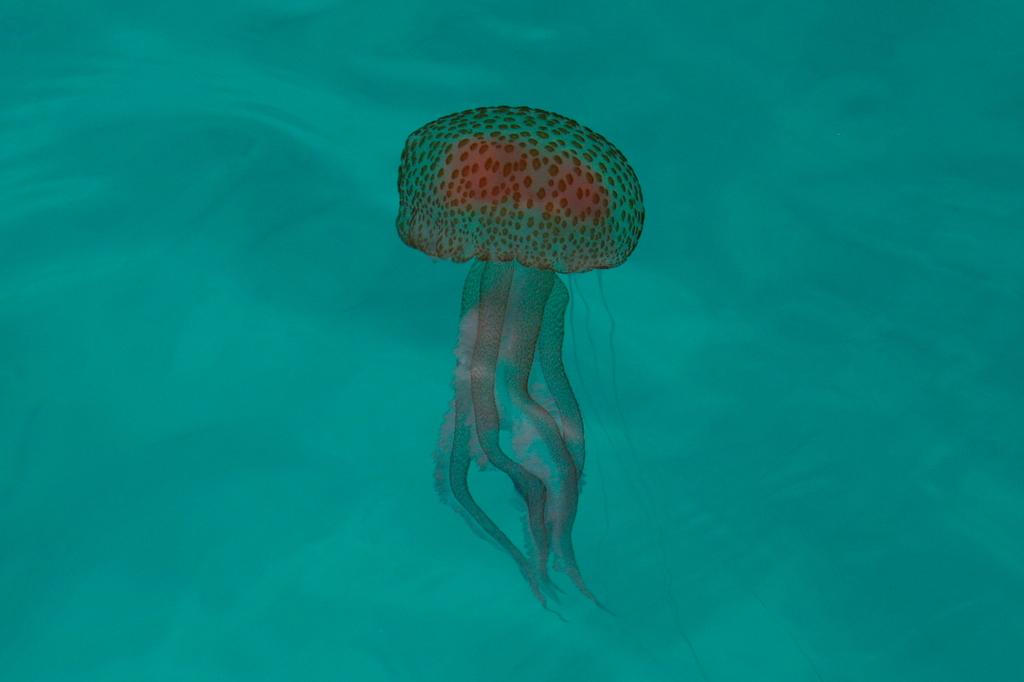What type of animal is in the image? There is a jellyfish in the image. Where is the jellyfish located? The jellyfish is in the water. What type of trees can be seen in the image? There are no trees present in the image; it features a jellyfish in the water. What type of canvas is used to create the image? The image is not a painting or drawing, so there is no canvas used to create it. 